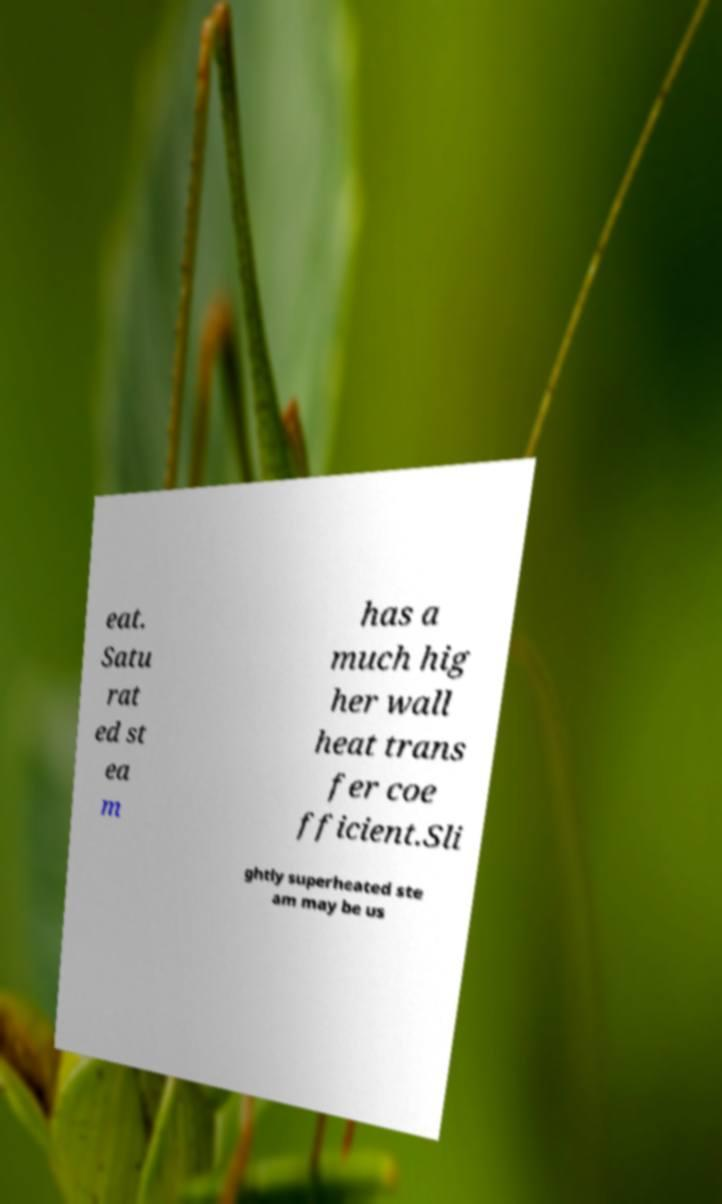Can you accurately transcribe the text from the provided image for me? eat. Satu rat ed st ea m has a much hig her wall heat trans fer coe fficient.Sli ghtly superheated ste am may be us 